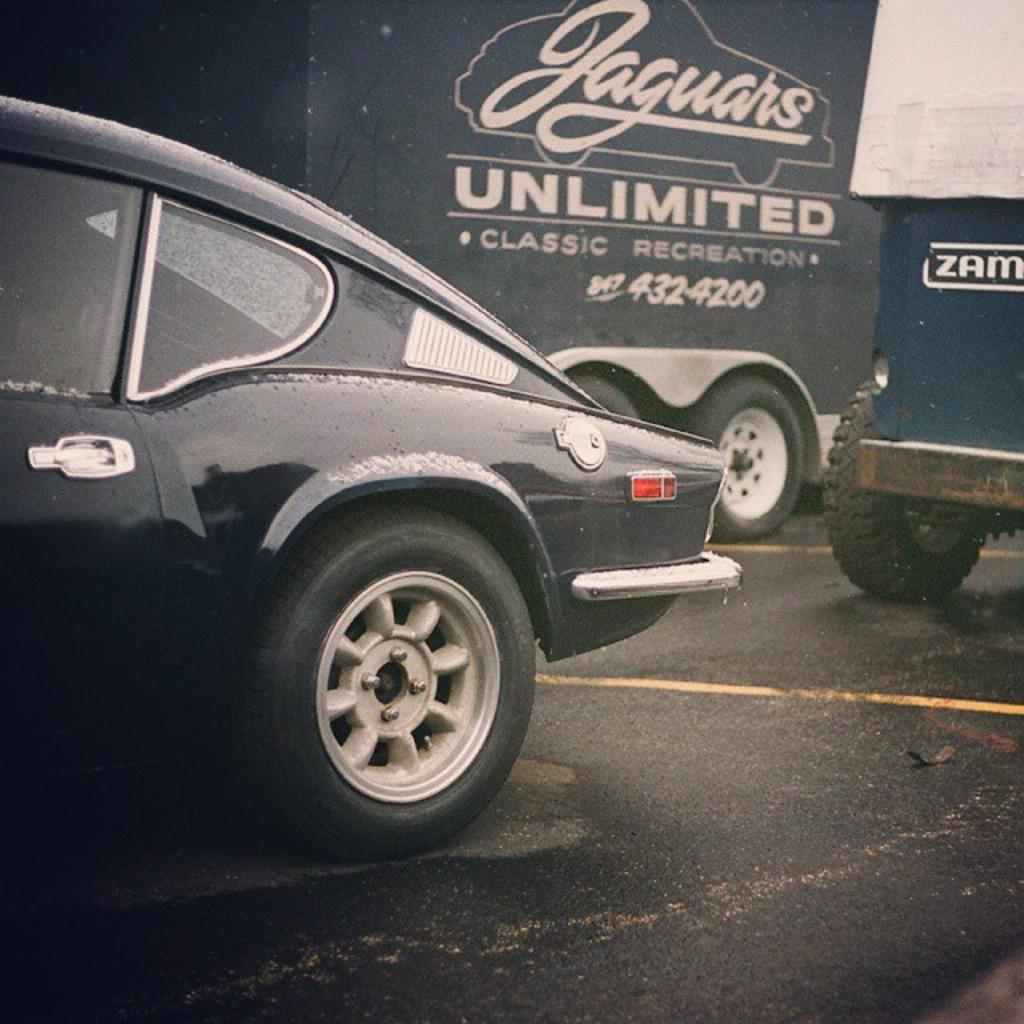What is the main subject of the image? The main subject of the image is a car on the road. Where is the car located on the road? The car is on the left side of the road. How many vehicles are visible on the road in the image? There are two vehicles visible on the road in the image. Where are the other vehicles located on the road? The other two vehicles are on the right side of the road. What type of lettuce is growing in the car's engine in the image? There is no lettuce or any vegetation growing in the car's engine in the image. 